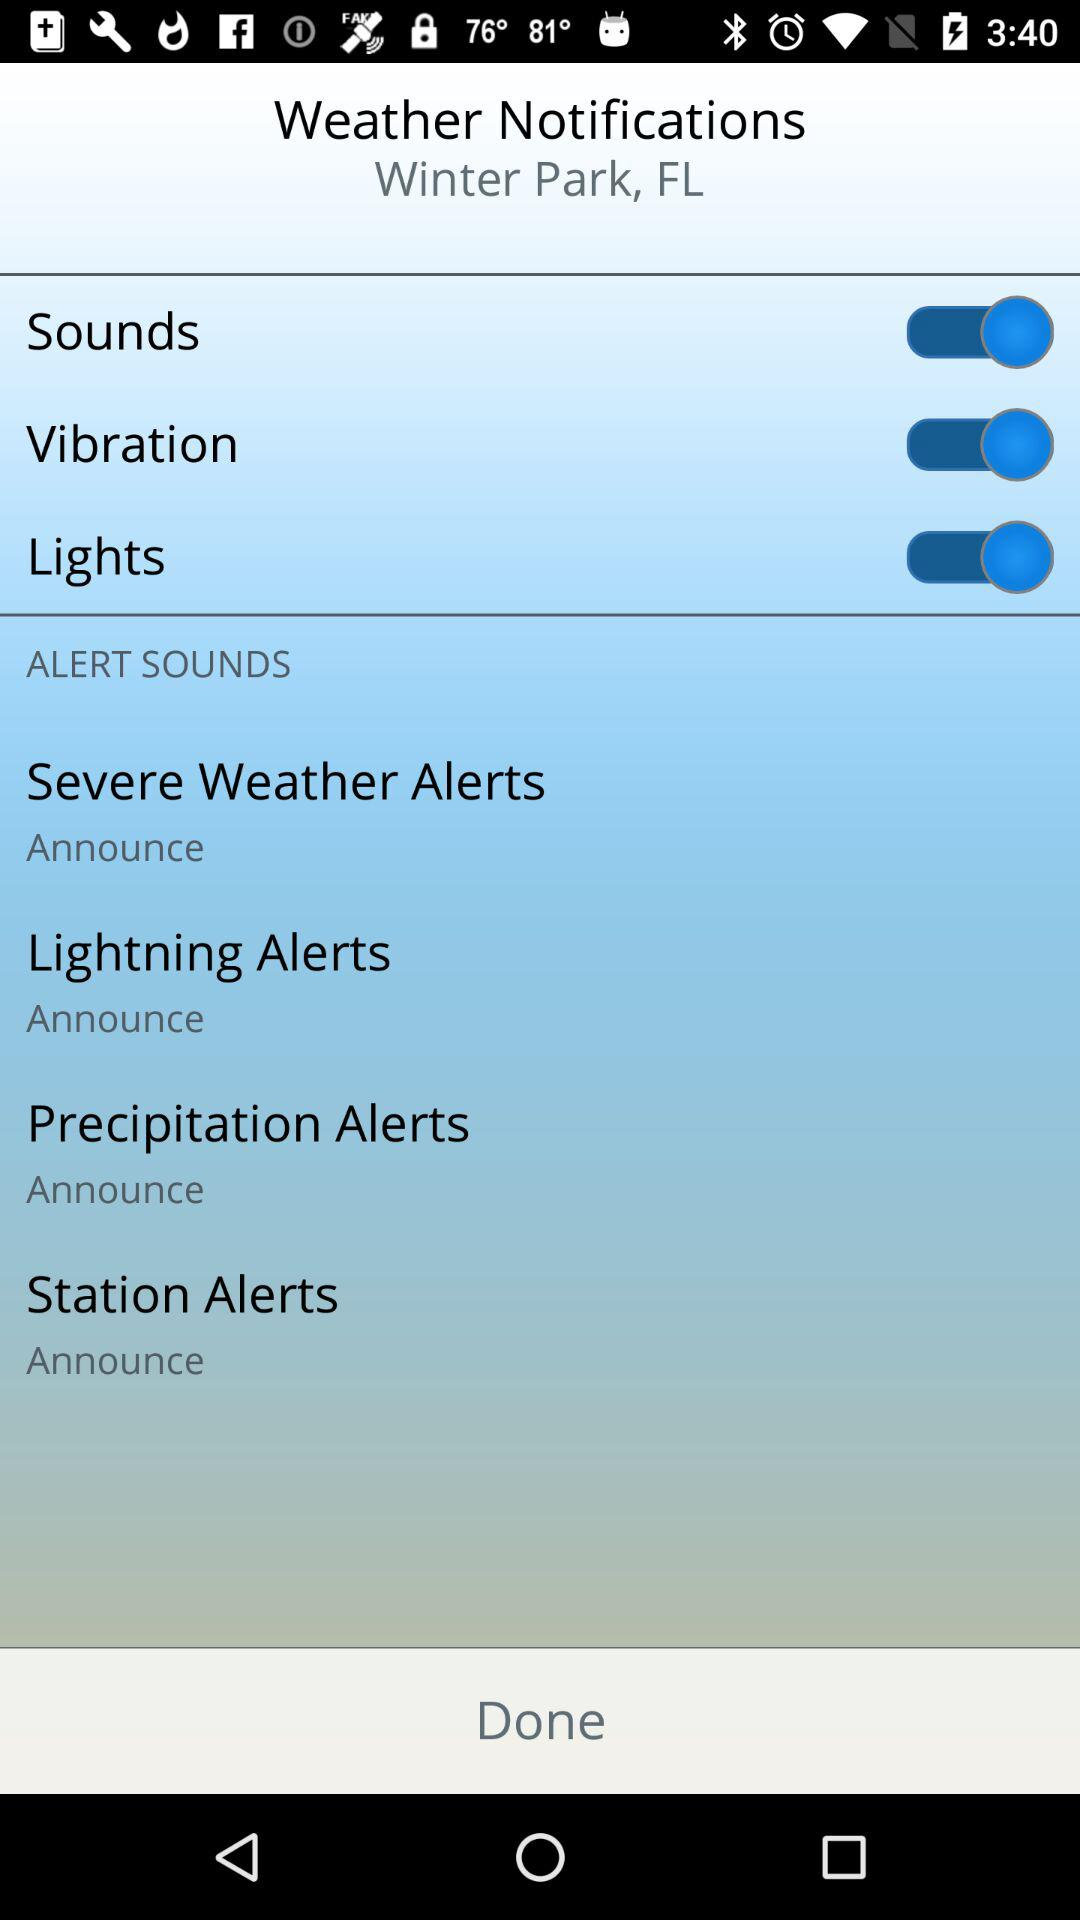What is the status of the "Lights" notification? The status is "on". 